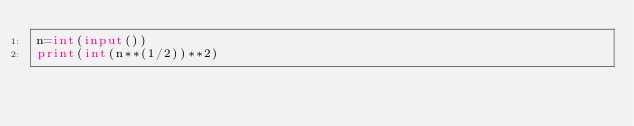<code> <loc_0><loc_0><loc_500><loc_500><_Python_>n=int(input())
print(int(n**(1/2))**2)</code> 